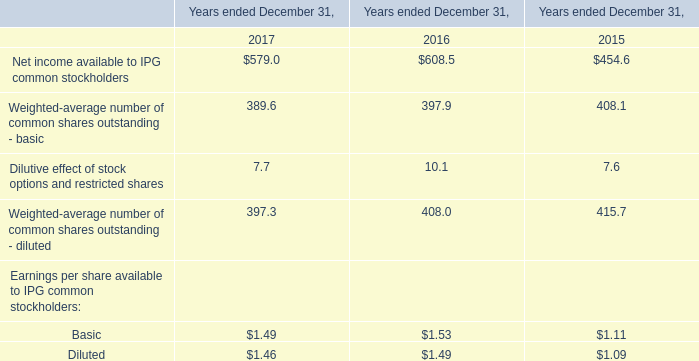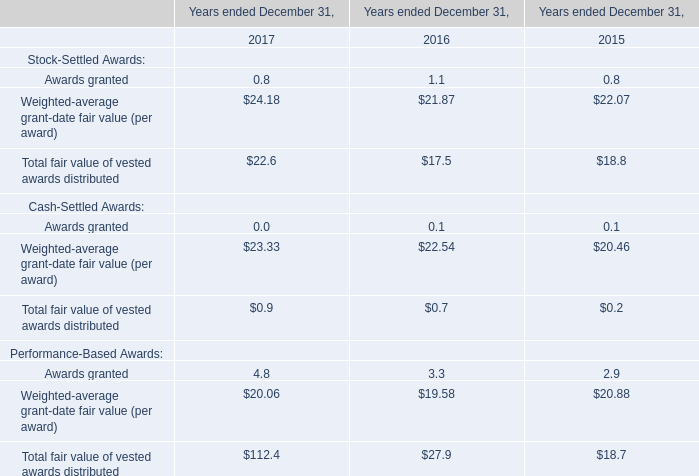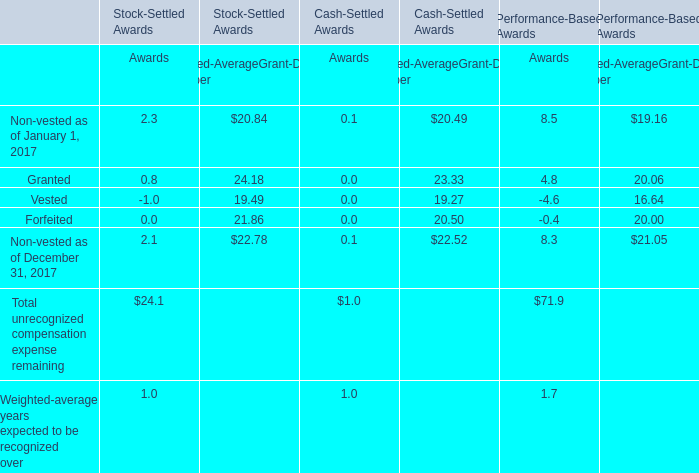Is the total amount of all elements inStock-Settled Awards greater than that in Performance-Based Awards forTotal unrecognized compensation expense remaining? 
Answer: No. 